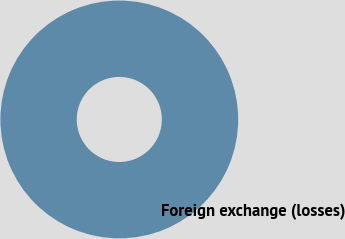Convert chart. <chart><loc_0><loc_0><loc_500><loc_500><pie_chart><fcel>Foreign exchange (losses)<nl><fcel>100.0%<nl></chart> 